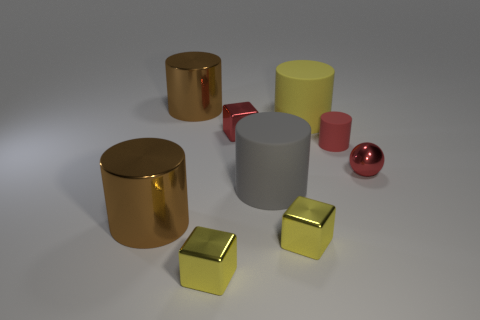Subtract all gray cylinders. How many cylinders are left? 4 Subtract all gray cylinders. How many cylinders are left? 4 Subtract all green cylinders. Subtract all red balls. How many cylinders are left? 5 Add 1 large gray cylinders. How many objects exist? 10 Subtract all cylinders. How many objects are left? 4 Add 8 tiny red cylinders. How many tiny red cylinders exist? 9 Subtract 0 purple blocks. How many objects are left? 9 Subtract all yellow metallic blocks. Subtract all small yellow cubes. How many objects are left? 5 Add 9 red metal blocks. How many red metal blocks are left? 10 